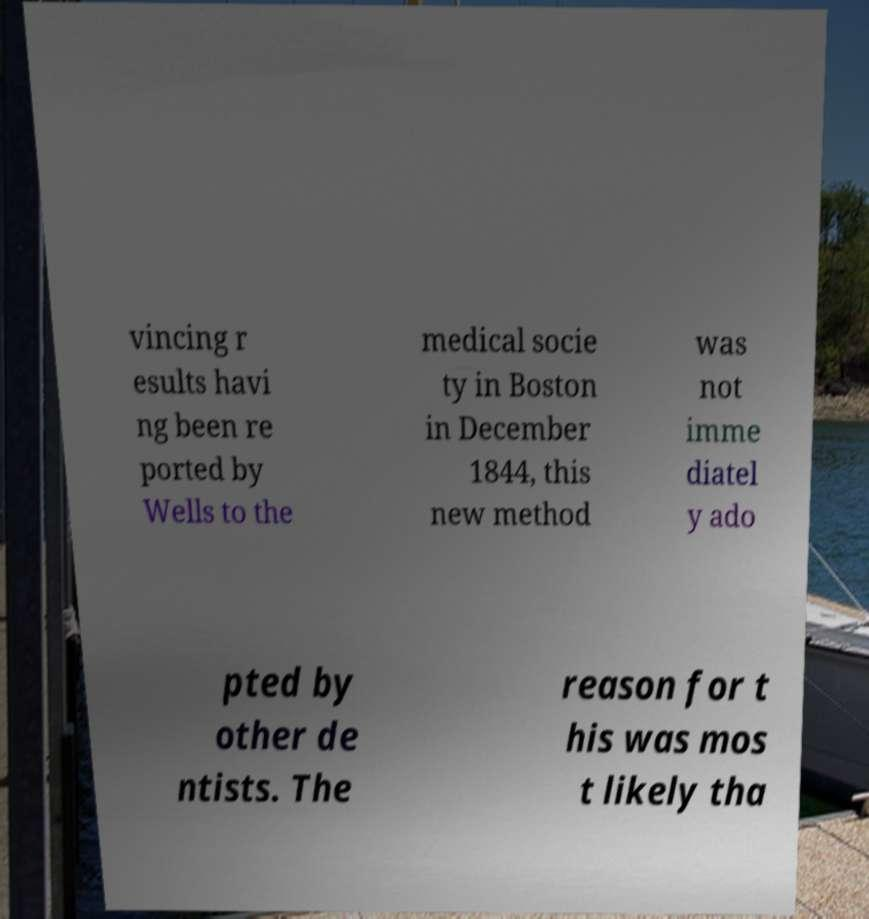Please identify and transcribe the text found in this image. vincing r esults havi ng been re ported by Wells to the medical socie ty in Boston in December 1844, this new method was not imme diatel y ado pted by other de ntists. The reason for t his was mos t likely tha 